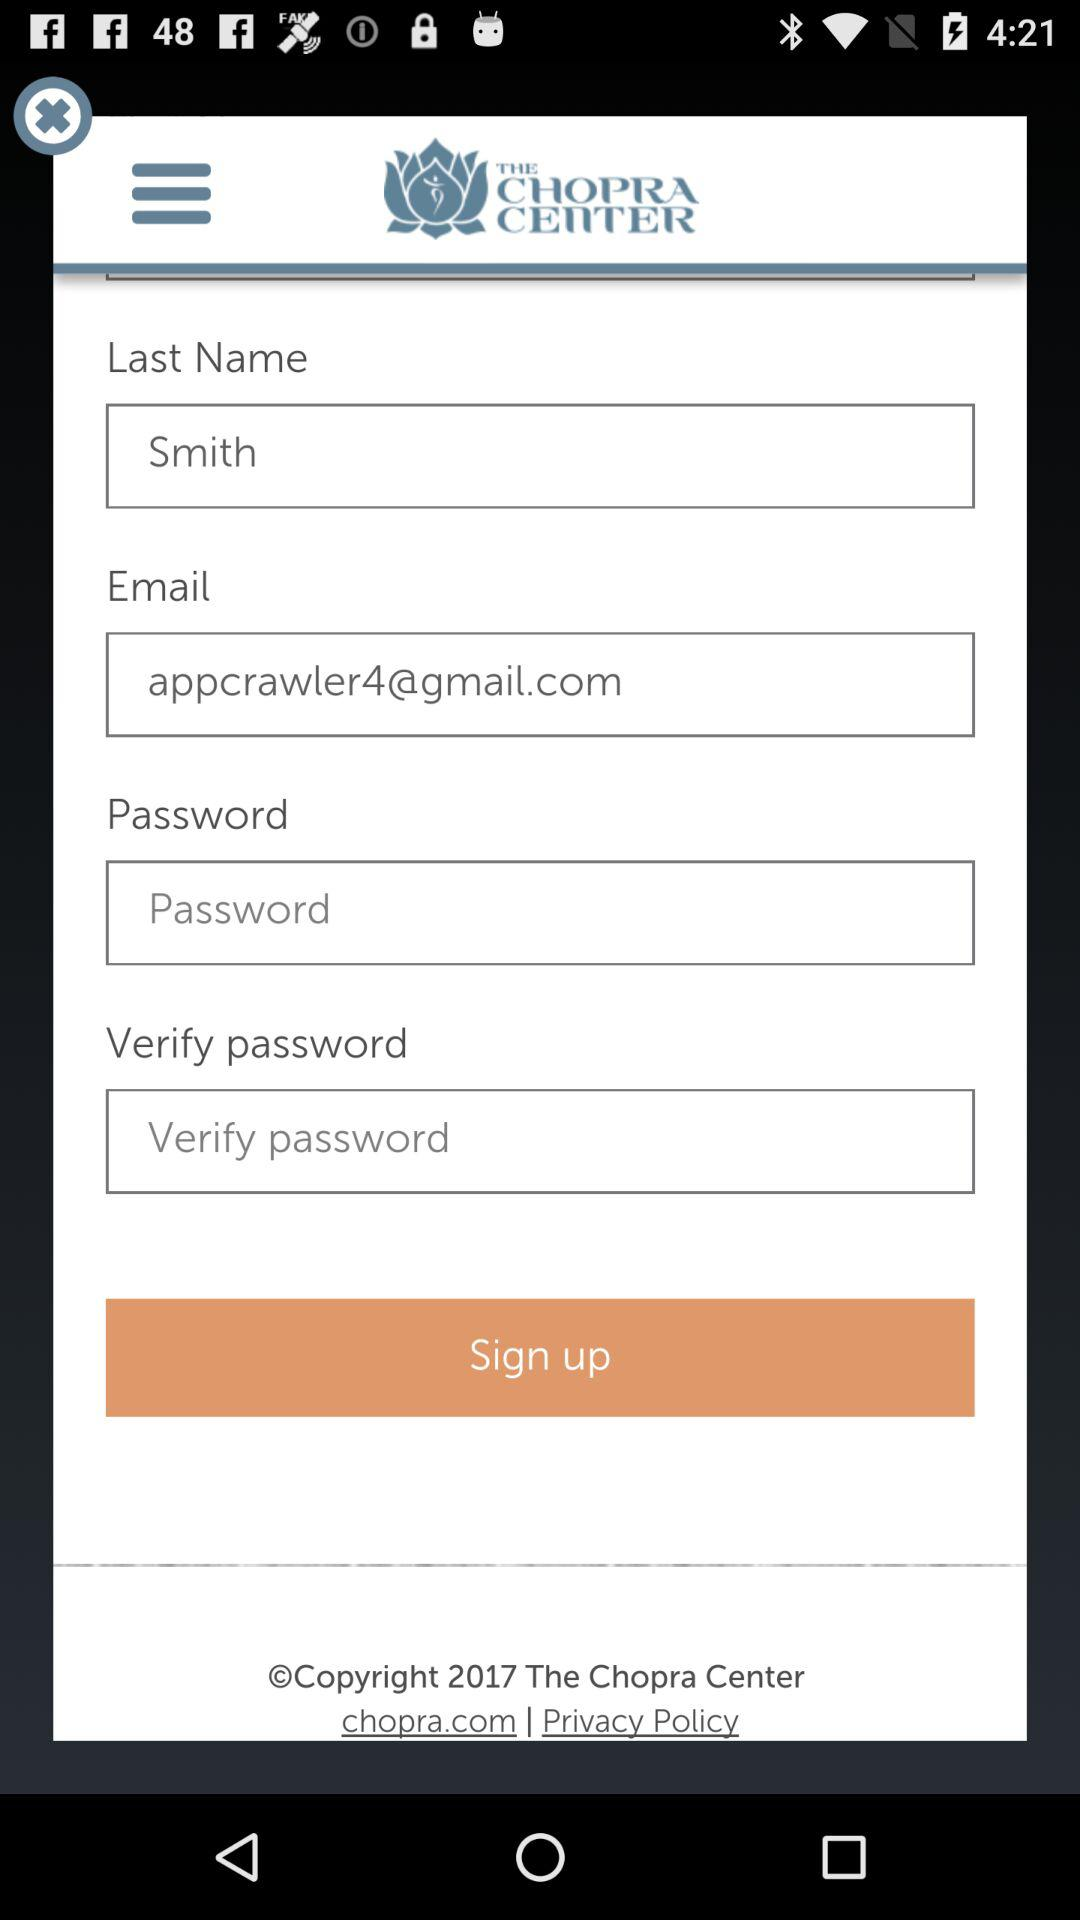What's the name of the Google mail address used by the user? The Google mail address used by the user is appcrawler4@gmail.com. 